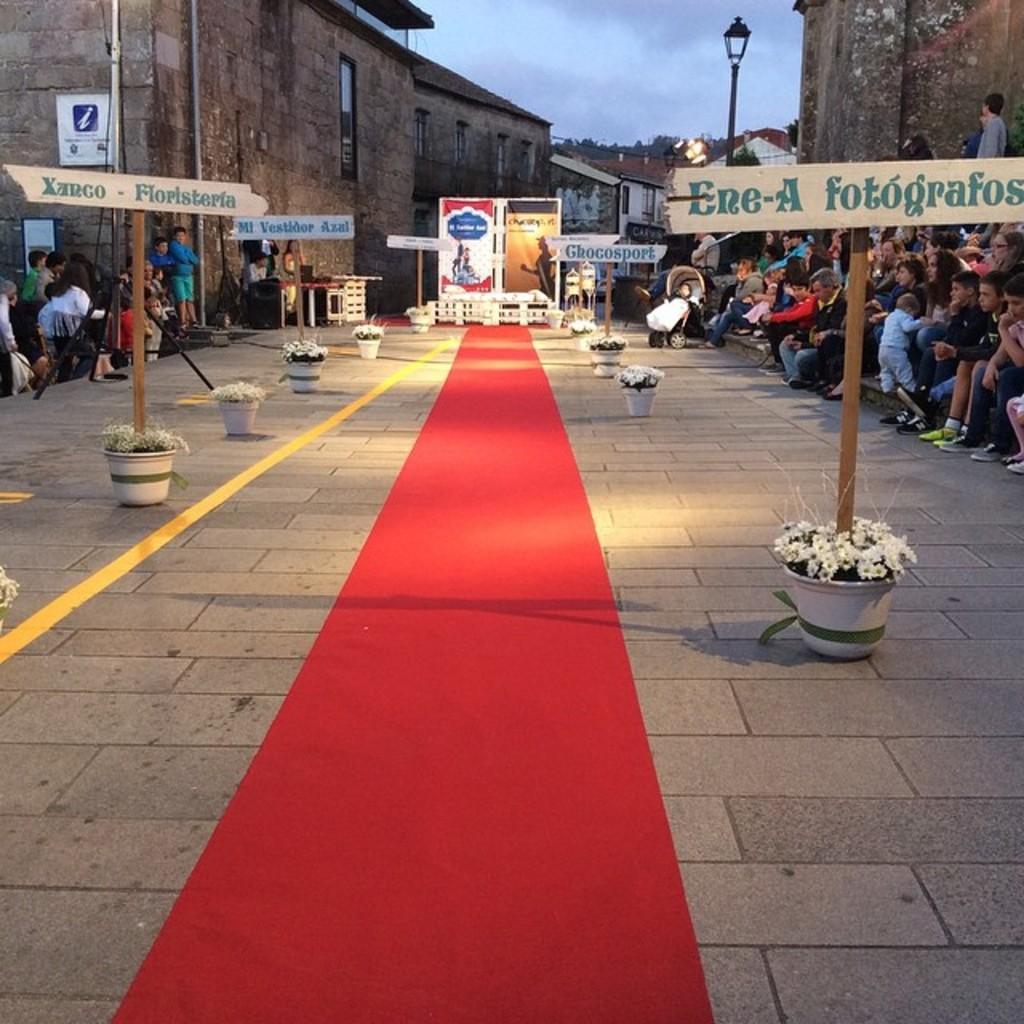In one or two sentences, can you explain what this image depicts? Here I can see a red color carpet is placed on the road. On both sides of this there are few flower pots placed and also I can see few boards. On both sides of the road there are many people sitting. In the background, I can see few buildings. At the top of the image I can see the sky. 